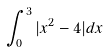Convert formula to latex. <formula><loc_0><loc_0><loc_500><loc_500>\int _ { 0 } ^ { 3 } | x ^ { 2 } - 4 | d x</formula> 